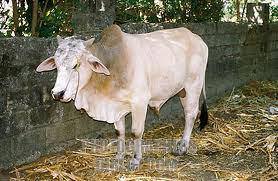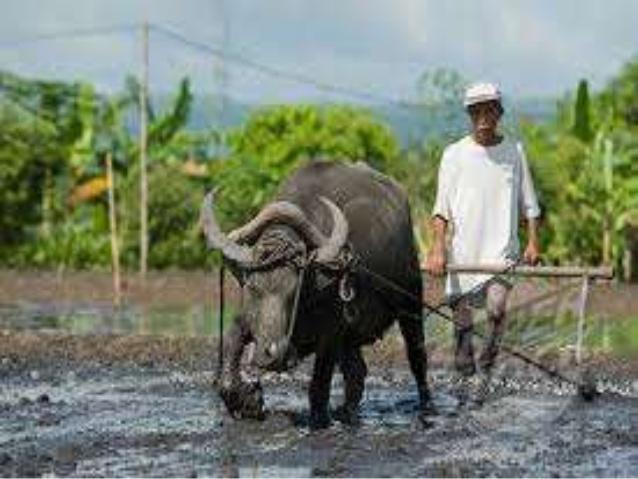The first image is the image on the left, the second image is the image on the right. Assess this claim about the two images: "Each image contains exactly one dark water buffalo, and no images contain humans.". Correct or not? Answer yes or no. No. The first image is the image on the left, the second image is the image on the right. For the images shown, is this caption "Two animals are near a small body of water." true? Answer yes or no. No. 